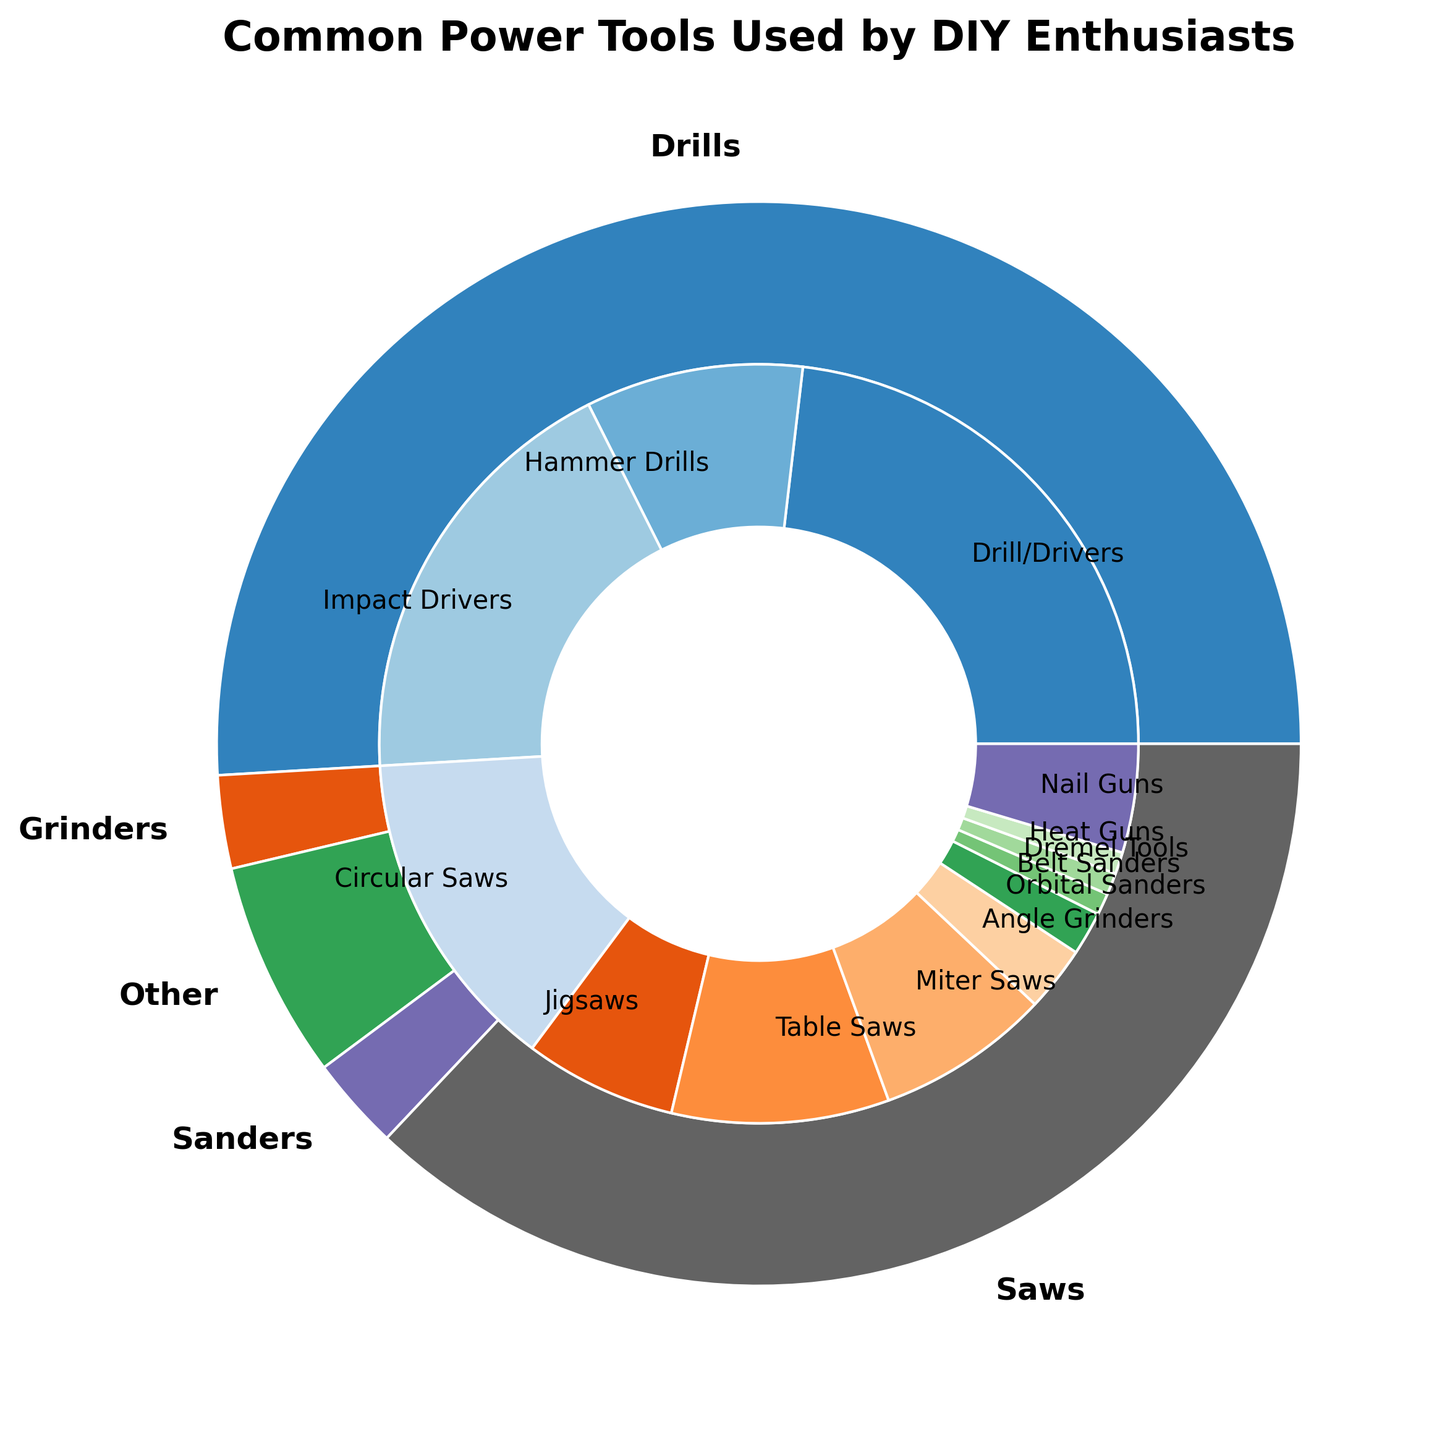How many different subcategories of power tools are there? To determine the number of subcategories, count the unique subcategories listed in the center of the nested pie chart.
Answer: 12 Which subcategory from the 'Saws' category has the highest usage percentage? Identify all the subcategories under 'Saws' by looking at the inner part of the pie chart and compare their usage percentages. Circular Saws (15%) has the highest usage percentage among them.
Answer: Circular Saws What is the total usage percentage of all 'Drills' subcategories combined? Add the usage percentages for all the 'Drills' subcategories: Drill/Drivers (25%), Hammer Drills (10%), and Impact Drivers (20%). 25% + 10% + 20% = 55%.
Answer: 55% Which category has the lowest total usage percentage? Look at the outer pie sections representing each category and find the one with the smallest section. 'Other' has the lowest total usage percentage (7%).
Answer: Other Compare the usage percentage of 'Drill/Drivers' and 'Nail Guns'. Which one is more used and by how much? Drill/Drivers have a usage percentage of 25% and Nail Guns have a usage percentage of 5%. The difference is 25% - 5% = 20%.
Answer: Drill/Drivers, by 20% What is the combined usage percentage of all 'Saws' subcategories? Add the usage percentages for all the 'Saws' subcategories: Circular Saws (15%), Jigsaws (7%), Table Saws (10%), and Miter Saws (8%). 15% + 7% + 10% + 8% = 40%.
Answer: 40% Which usage percentage is larger: 'Impact Drivers' or the sum of 'Orbital Sanders' and 'Belt Sanders'? Compare the usage percentage of Impact Drivers (20%) with the combined usage percentages of Orbital Sanders (2%) and Belt Sanders (1%). 20% is larger than 2% + 1% = 3%.
Answer: Impact Drivers How does the usage percentage of 'Table Saws' compare to the combined usage of 'Heat Guns' and 'Dremel Tools'? Table Saws have a usage percentage of 10%, while the combined usage of Heat Guns (1%) and Dremel Tools (1%) is 2%.
Answer: Table Saws have a higher usage by 8% Which categories contain more subcategories: 'Drills' or 'Saws'? Count the subcategories for each category. 'Drills' has 3 subcategories (Drill/Drivers, Hammer Drills, Impact Drivers) and 'Saws' has 4 subcategories (Circular Saws, Jigsaws, Table Saws, Miter Saws).
Answer: Saws What is the difference in usage percentage between 'Angle Grinders' and 'Miter Saws'? Look at the inner pie sections for each tool. Angle Grinders have a usage percentage of 3%, and Miter Saws have 8%. The difference is 8% - 3% = 5%.
Answer: 5% 